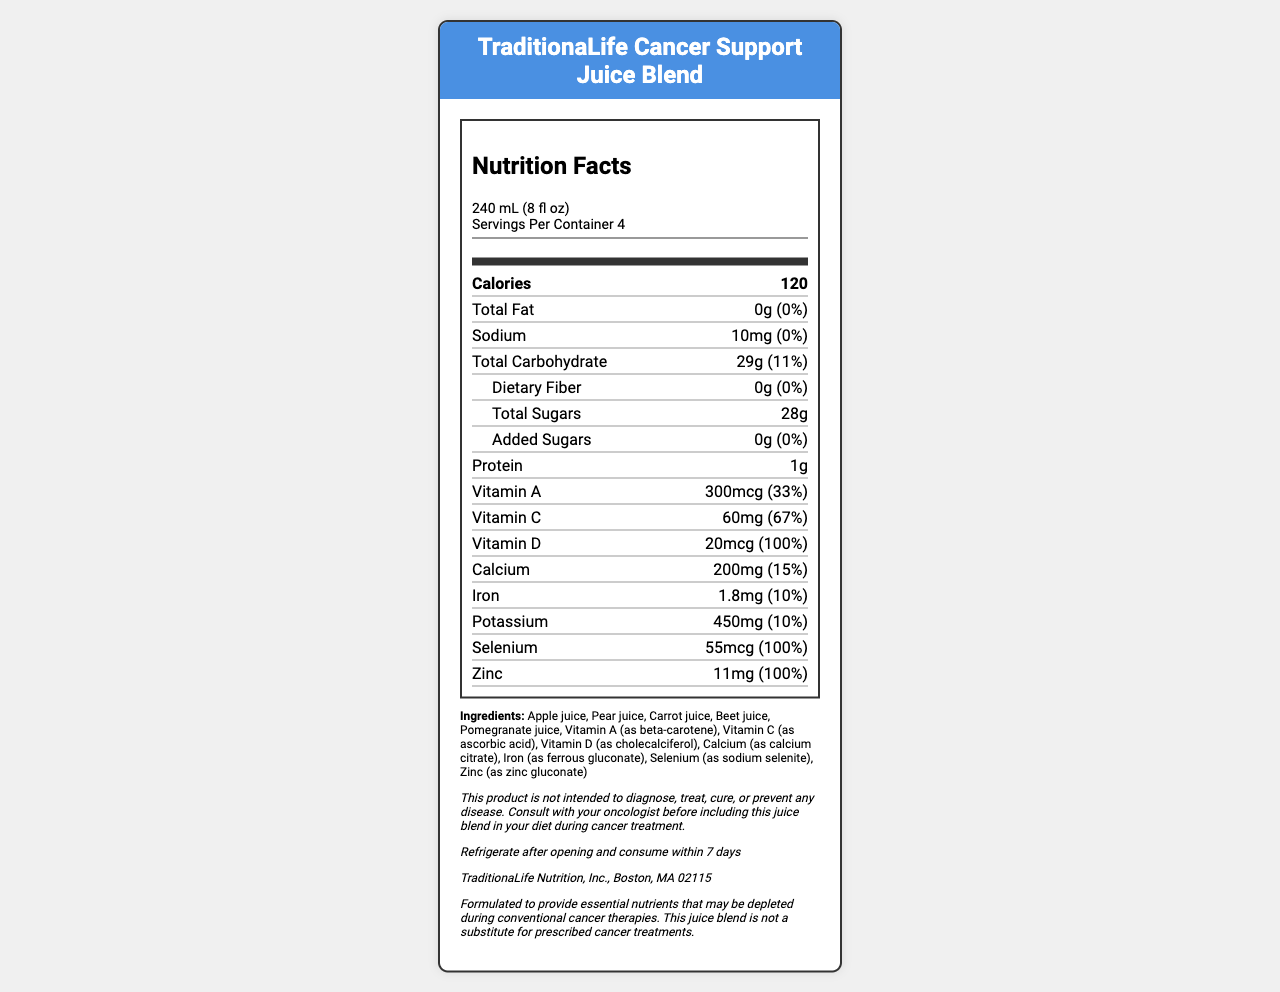what is the serving size? The serving size is clearly listed in the first section of the nutrition facts label.
Answer: 240 mL (8 fl oz) how many servings are in the container? The label states "Servings Per Container 4" right below the serving size information.
Answer: 4 how much sodium is in one serving? The nutrition facts label lists sodium content as "10mg" for one serving.
Answer: 10 mg what percentage of the daily value of Vitamin D does one serving provide? The label indicates that one serving provides "20mcg" of Vitamin D which is 100% of the daily value.
Answer: 100% how much added sugar does one serving contain? The label indicates that added sugars in one serving amount to "0g".
Answer: 0g what ingredients are used in the juice blend? The list of ingredients is provided in the document under the "Ingredients" section.
Answer: Apple juice, Pear juice, Carrot juice, Beet juice, Pomegranate juice, Vitamin A (as beta-carotene), Vitamin C (as ascorbic acid), Vitamin D (as cholecalciferol), Calcium (as calcium citrate), Iron (as ferrous gluconate), Selenium (as sodium selenite), Zinc (as zinc gluconate) what is the total carbohydrate content in one serving? The total carbohydrate content for one serving is listed as "29g".
Answer: 29g which vitamin provides the highest daily value percentage in this juice blend? A. Vitamin A B. Vitamin C C. Vitamin D D. Selenium E. Zinc Selenium provides 100% of the daily value, which is the highest among the listed vitamins and minerals.
Answer: D what is the manufacturer's location? A. New York, NY B. Los Angeles, CA C. Boston, MA D. San Francisco, CA The juice blend is manufactured by "TraditionaLife Nutrition, Inc., Boston, MA 02115".
Answer: C does this product contain any fat? The nutrition facts lists Total Fat as "0g", indicating there is no fat in the product.
Answer: No what is the main idea of this document? The document includes sections on nutrition facts, ingredients, disclaimers, storage instructions, and manufacturer information to help consumers understand the nutrient value and purpose of the juice blend.
Answer: This document provides detailed nutrition facts and ingredient information for the TraditionaLife Cancer Support Juice Blend, highlighting its nutritional content and the disclaimer that it should not replace conventional cancer therapies. what is the fiber content in each serving? The label does not provide fiber content information, only stating "Dietary Fiber: 0g". It does not clarify if there is any other type of fiber.
Answer: Not enough information 